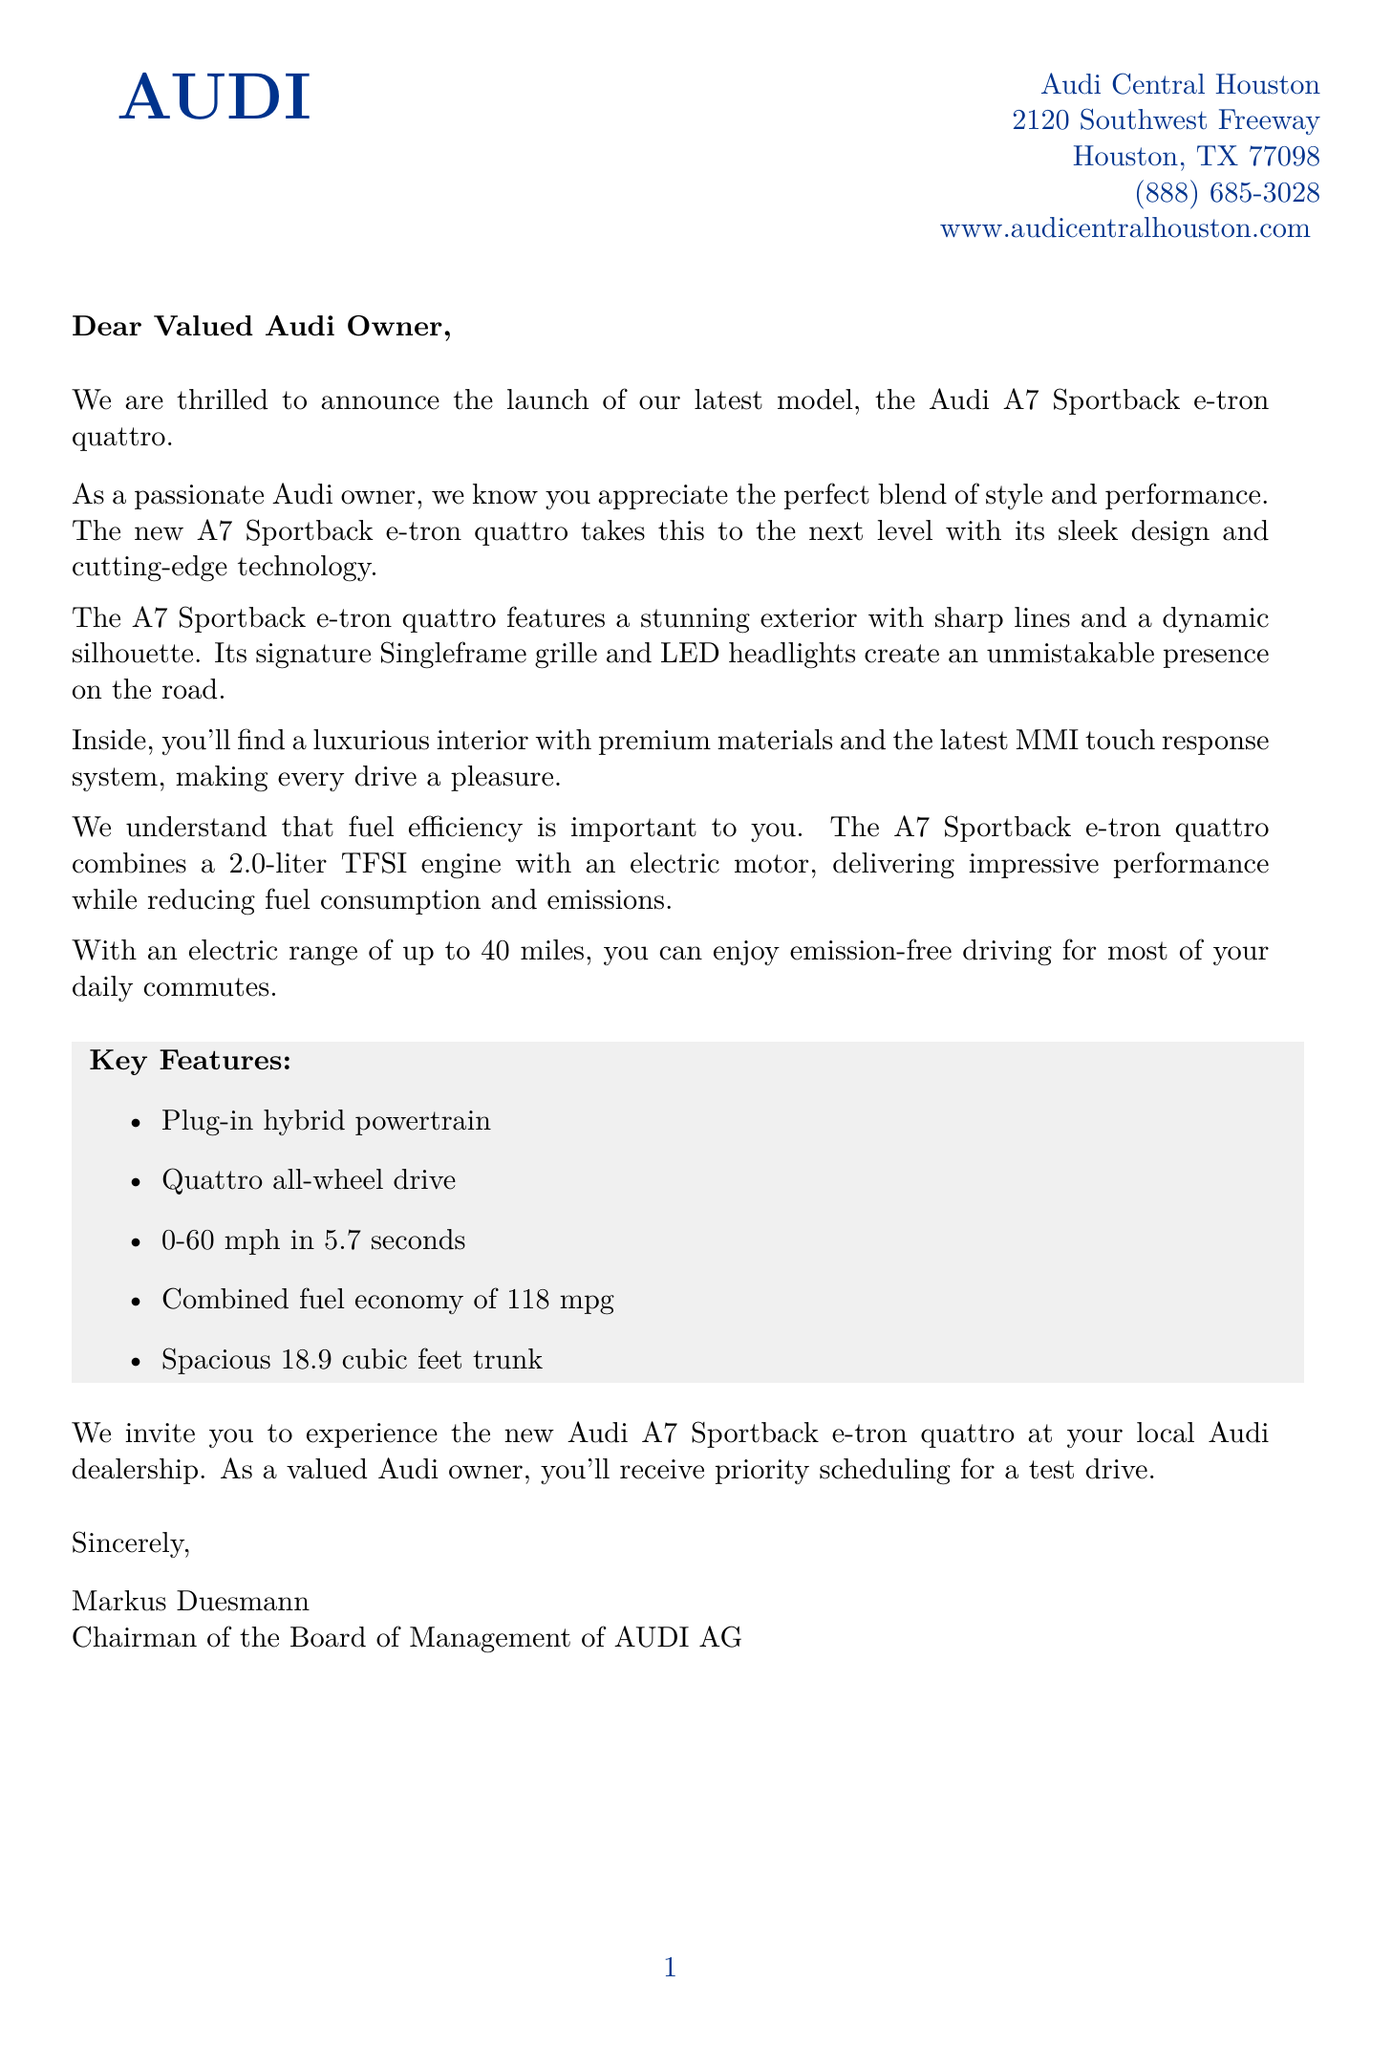what is the name of the new model? The new model mentioned in the document is the Audi A7 Sportback e-tron quattro.
Answer: Audi A7 Sportback e-tron quattro how much is the electric range? The electric range of the A7 Sportback e-tron quattro is up to 40 miles.
Answer: up to 40 miles what type of engine does the new model have? The A7 Sportback e-tron quattro combines a 2.0-liter TFSI engine with an electric motor.
Answer: 2.0-liter TFSI engine with an electric motor what dealership is mentioned in the letter? The letter mentions Audi Central Houston as the dealership.
Answer: Audi Central Houston what is the combined fuel economy of the A7 Sportback e-tron quattro? The combined fuel economy of the A7 Sportback e-tron quattro is 118 mpg.
Answer: 118 mpg which premium sound system is offered in the new model? The document lists the Bang & Olufsen 3D Premium Sound System as the premium sound system.
Answer: Bang & Olufsen 3D Premium Sound System how many seconds does it take to accelerate from 0-60 mph? The A7 Sportback e-tron quattro accelerates from 0-60 mph in 5.7 seconds.
Answer: 5.7 seconds what is the name of the Chairman of the Board of Management? The Chairman of the Board of Management of AUDI AG is Markus Duesmann.
Answer: Markus Duesmann 